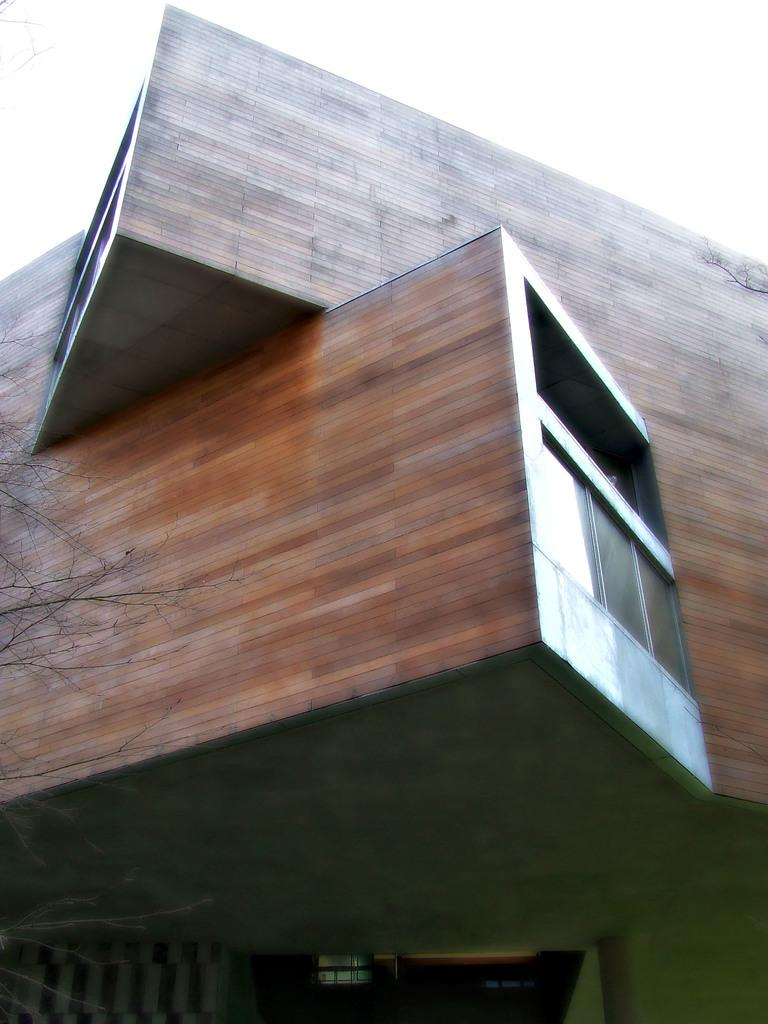Where was the image taken? The image was taken outdoors. What is the main subject in the image? The main subject in the image is a building. Can you describe the building in the image? The building has walls, windows, a door, and a roof. What else can be seen in the image besides the building? There is there a tree on the left side of the image. What is the title of the office depicted in the image? There is no office present in the image, and therefore no title can be assigned to it. What season is it in the image, given the presence of spring flowers? There is no mention of spring flowers or any seasonal indicators in the image. 